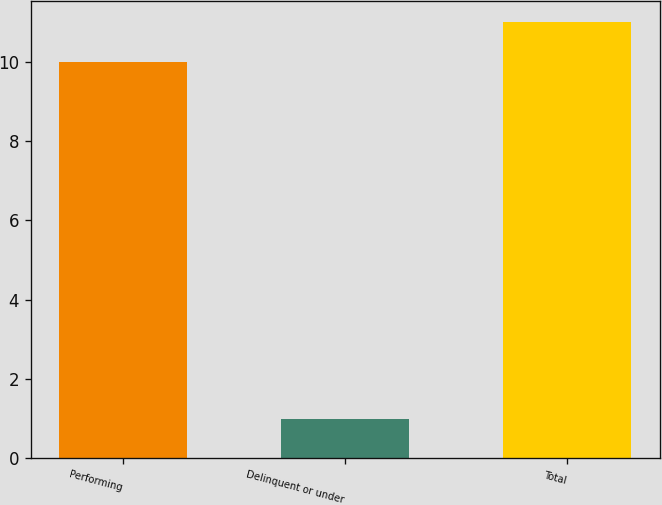Convert chart. <chart><loc_0><loc_0><loc_500><loc_500><bar_chart><fcel>Performing<fcel>Delinquent or under<fcel>Total<nl><fcel>10<fcel>1<fcel>11<nl></chart> 